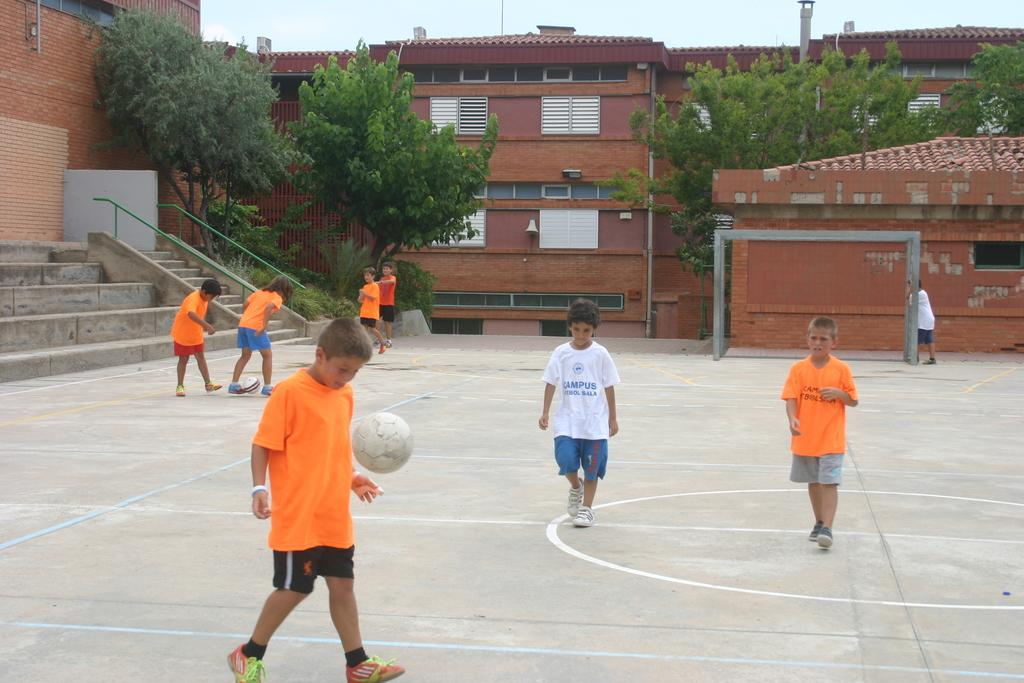Who is present in the image? There are children in the image. What is happening with the ball in the image? A ball is in the air. What can be seen in the background of the image? There are buildings, steps, windows, and trees in the background. What type of rake is being used by the children in the image? There is no rake present in the image; the children are not using any tools or equipment. 